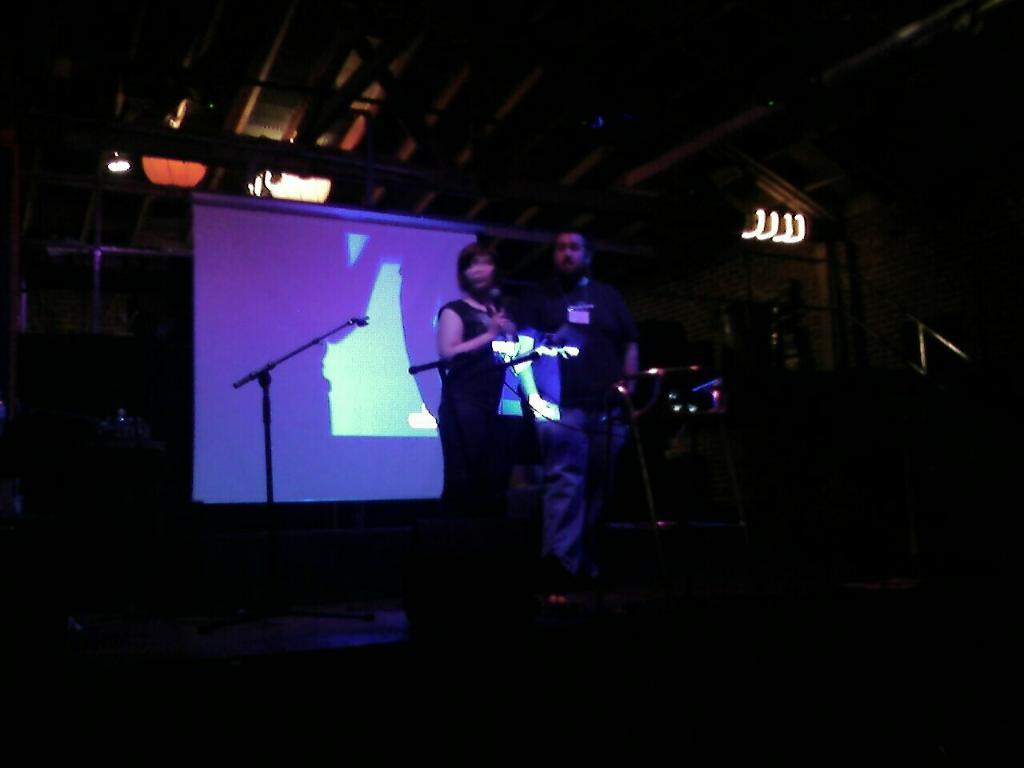Who can be seen in the image standing on the stage? There is a lady and a man standing on a stage in the image. What objects are in front of the lady and the man? There are microphones in front of them. What can be seen in the background of the stage? There is a screen in the background of the image. What type of lighting is present on the stage? There are lights on the roof of the stage. Can you see any icicles hanging from the roof of the stage in the image? There are no icicles visible in the image; the stage appears to be indoors and well-lit. 